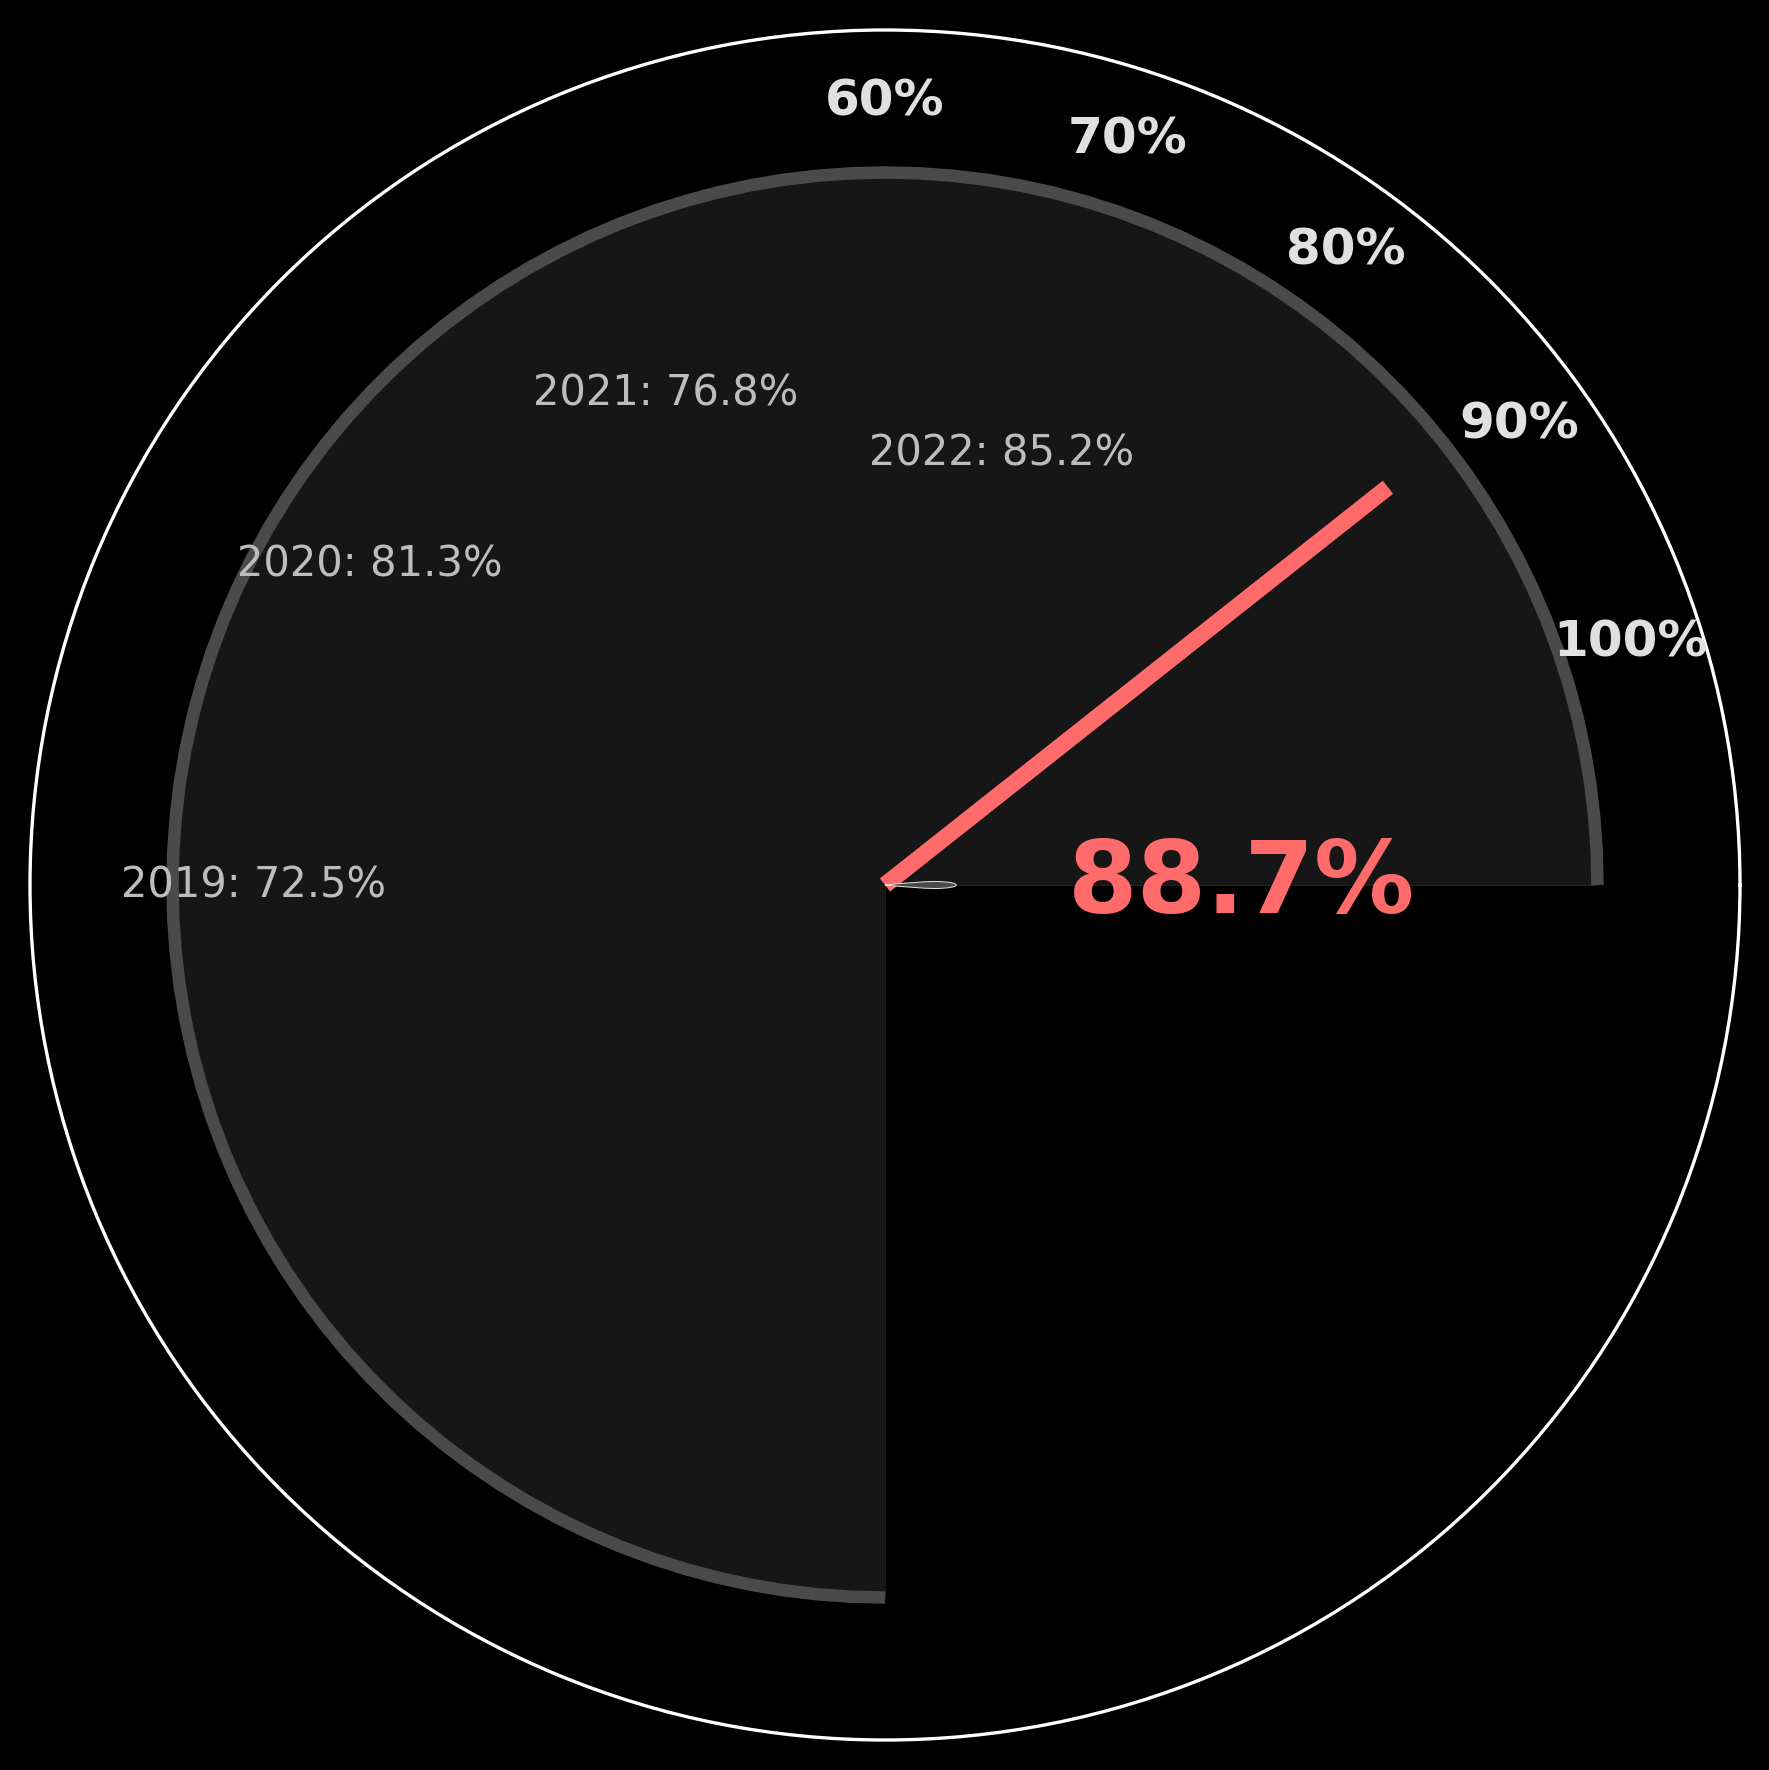What is the title of the gauge chart? The information is located at the upper part of the figure where the title is often displayed.
Answer: J. Reuben Clark Law School What is the success rate displayed in the center of the gauge? The central part of the gauge chart shows the latest success rate data point.
Answer: 88.7% Which year's success rate is indicated by the needle? Near the bottom of the figure, the subtitle provides the year corresponding to the current success rate displayed by the needle.
Answer: 2023 What is the color of the needle on the gauge chart? The needle is a distinctive element in the gauge chart, typically with a unique color.
Answer: Red What is the range of success rates displayed on the gauge chart? The gauge chart has labeled marks on the perimeter indicating the range of possible values.
Answer: 60% to 100% Which year had the lowest success rate? Look at the annotations near the left side of the figure, where previous years' success rates are mentioned. Identify the lowest value.
Answer: 2019 Is the success rate in 2023 greater than that in 2022? Compare the value annotated for 2023 with that of 2022.
Answer: Yes How much did the success rate increase from 2019 to 2023? Subtract the success rate of 2019 from that of 2023: 88.7% - 72.5%.
Answer: 16.2% Which year showed the highest improvement in success rate compared to the previous year? Calculate the yearly changes: 2020-2019, 2021-2020, 2022-2021, 2023-2022 and identify the highest difference.
Answer: 2022 How many years are shown in the historical success rates at the left of the figure? Count the number of different years mentioned in the annotations on the left side.
Answer: Four 